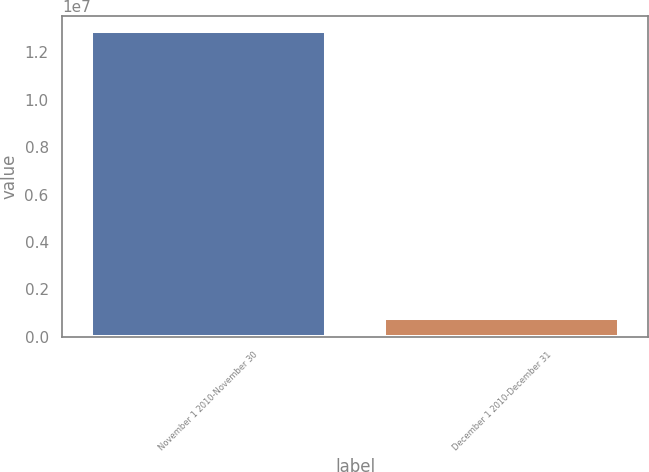Convert chart to OTSL. <chart><loc_0><loc_0><loc_500><loc_500><bar_chart><fcel>November 1 2010-November 30<fcel>December 1 2010-December 31<nl><fcel>1.29013e+07<fcel>798676<nl></chart> 